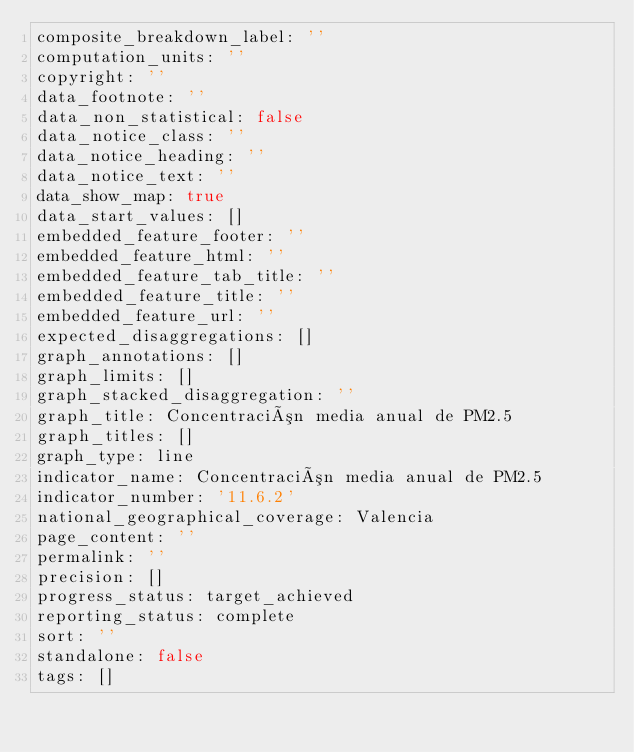<code> <loc_0><loc_0><loc_500><loc_500><_YAML_>composite_breakdown_label: ''
computation_units: ''
copyright: ''
data_footnote: ''
data_non_statistical: false
data_notice_class: ''
data_notice_heading: ''
data_notice_text: ''
data_show_map: true
data_start_values: []
embedded_feature_footer: ''
embedded_feature_html: ''
embedded_feature_tab_title: ''
embedded_feature_title: ''
embedded_feature_url: ''
expected_disaggregations: []
graph_annotations: []
graph_limits: []
graph_stacked_disaggregation: ''
graph_title: Concentración media anual de PM2.5
graph_titles: []
graph_type: line
indicator_name: Concentración media anual de PM2.5
indicator_number: '11.6.2'
national_geographical_coverage: Valencia
page_content: ''
permalink: ''
precision: []
progress_status: target_achieved
reporting_status: complete
sort: ''
standalone: false
tags: []

</code> 